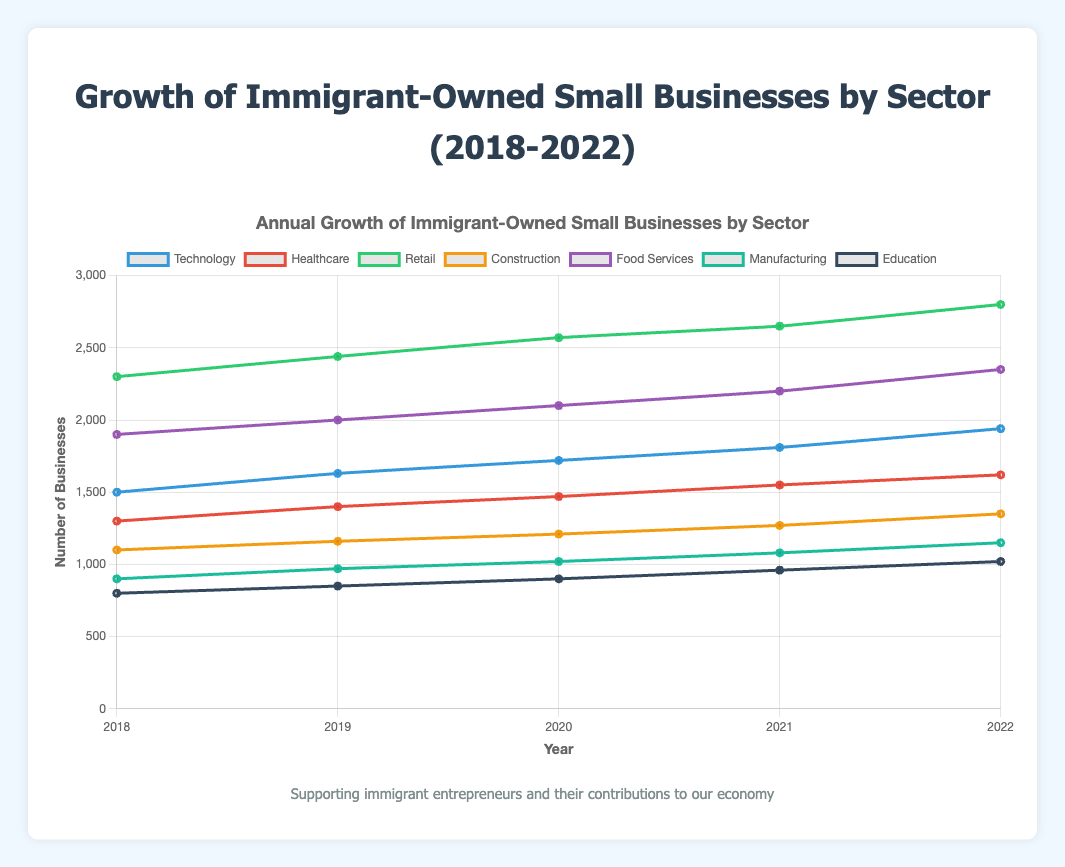How many more immigrant-owned small businesses were there in the Food Services sector than in the Education sector in 2022? In 2022, there were 2,350 businesses in the Food Services sector and 1,020 businesses in the Education sector. Subtract the number of businesses in Education from the number in Food Services: 2,350 - 1,020 = 1,330
Answer: 1,330 Which sector experienced the highest growth in immigrant-owned small businesses from 2018 to 2022? Calculate the growth for each sector by subtracting the number of businesses in 2018 from the number in 2022. Compare the growth numbers: 
- Technology: 1940 - 1500 = 440
- Healthcare: 1620 - 1300 = 320
- Retail: 2800 - 2300 = 500
- Construction: 1350 - 1100 = 250
- Food Services: 2350 - 1900 = 450
- Manufacturing: 1150 - 900 = 250
- Education: 1020 - 800 = 220
Retail experienced the highest growth with 500 additional businesses
Answer: Retail In which year did the Construction sector see the smallest increase in the number of immigrant-owned small businesses compared to the previous year? Calculate the year-over-year increase for the Construction sector:
- 2019: 1160 - 1100 = 60
- 2020: 1210 - 1160 = 50
- 2021: 1270 - 1210 = 60
- 2022: 1350 - 1270 = 80 
The smallest increase was from 2019 to 2020, which was 50
Answer: 2020 Which sector had the closest number of immigrant-owned small businesses in 2021 and 2022? Calculate the difference in number of businesses for each sector between 2021 and 2022:
- Technology: 1940 - 1810 = 130
- Healthcare: 1620 - 1550 = 70
- Retail: 2800 - 2650 = 150
- Construction: 1350 - 1270 = 80
- Food Services: 2350 - 2200 = 150
- Manufacturing: 1150 - 1080 = 70
- Education: 1020 - 960 = 60
The sectors with the smallest differences are Healthcare and Manufacturing, both with a difference of 70
Answer: Healthcare, Manufacturing What is the average number of immigrant-owned small businesses in the Technology sector from 2018 to 2022? Calculate the sum of the number of businesses for all years and divide by the number of years:
(1500 + 1630 + 1720 + 1810 + 1940) / 5 = 8600 / 5 = 1720
Answer: 1720 